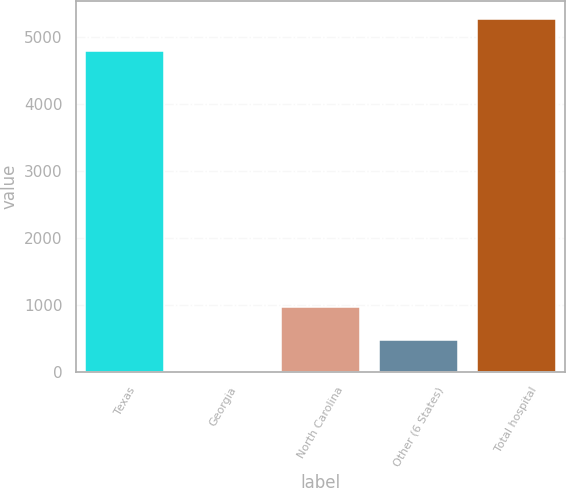<chart> <loc_0><loc_0><loc_500><loc_500><bar_chart><fcel>Texas<fcel>Georgia<fcel>North Carolina<fcel>Other (6 States)<fcel>Total hospital<nl><fcel>4793<fcel>3<fcel>968.4<fcel>485.7<fcel>5275.7<nl></chart> 